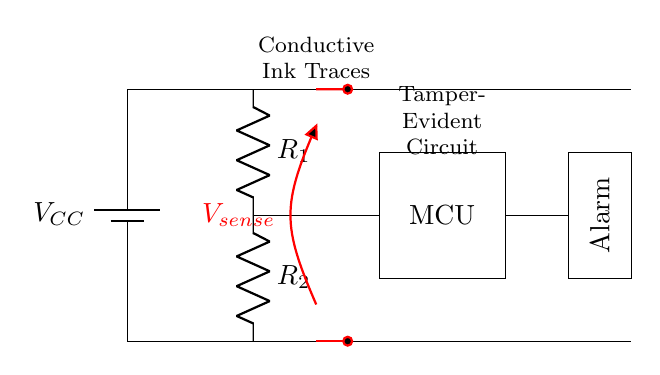What is the main function of the red traces in the circuit? The red traces represent conductive ink tracks that connect different parts of the circuit and play a role in the tamper-evident mechanism.
Answer: Conductive ink tracks What components are connected in series in the circuit? The resistors R1 and R2 are connected in series because they are aligned one after the other between the two voltage levels, allowing current to flow through them sequentially.
Answer: R1 and R2 What does the alarm indicate in this circuit? The alarm is triggered by detecting alterations in the circuit caught by the microcontroller, typically indicating a tampering attempt or breach.
Answer: Tampering detection What is the voltage supply denoted in the diagram? The voltage supply is denoted as V sub CC, which is the power source for the entire circuit.
Answer: VCC What is the purpose of the microcontroller in this tamper-evident circuit? The microcontroller processes the signals from the conductive ink traces and determines if a tampering event has occurred, after which it activates the alarm if necessary.
Answer: Signal processing and alarm activation How many resistors are present in the circuit? There are two resistors, R1 and R2, used to form part of the detecting mechanism within the tamper-evident features of the circuit.
Answer: Two 